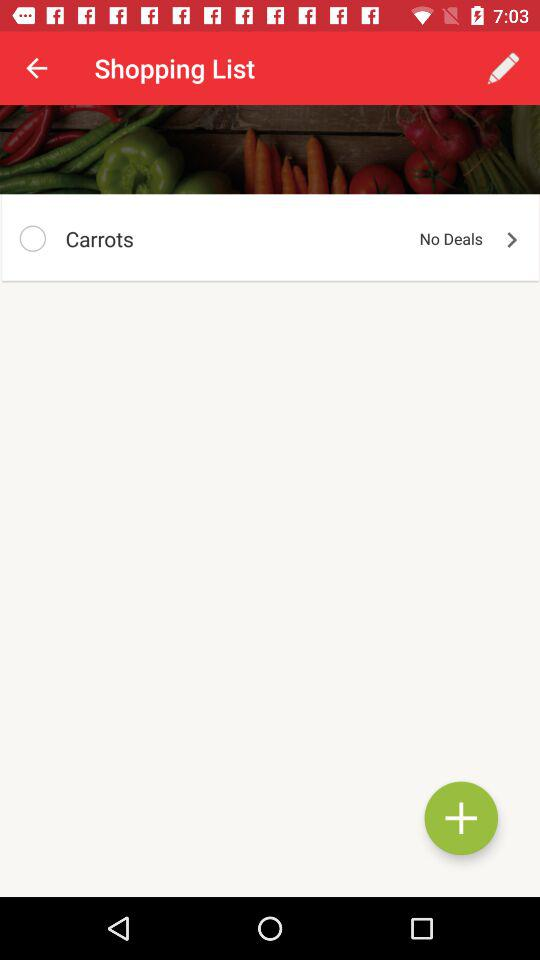What is the name of the item on the shopping list? The name of the item on the shopping list is "Carrots". 